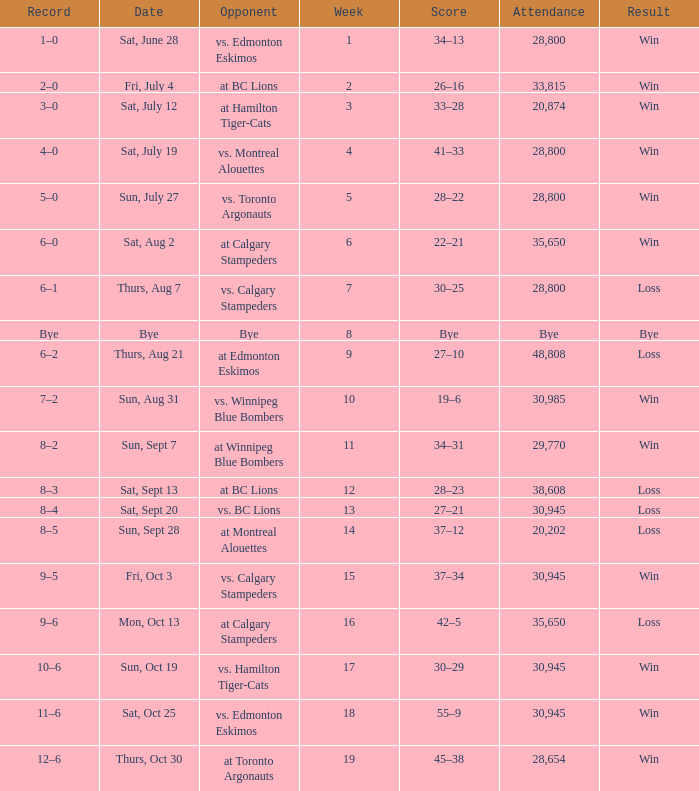Would you mind parsing the complete table? {'header': ['Record', 'Date', 'Opponent', 'Week', 'Score', 'Attendance', 'Result'], 'rows': [['1–0', 'Sat, June 28', 'vs. Edmonton Eskimos', '1', '34–13', '28,800', 'Win'], ['2–0', 'Fri, July 4', 'at BC Lions', '2', '26–16', '33,815', 'Win'], ['3–0', 'Sat, July 12', 'at Hamilton Tiger-Cats', '3', '33–28', '20,874', 'Win'], ['4–0', 'Sat, July 19', 'vs. Montreal Alouettes', '4', '41–33', '28,800', 'Win'], ['5–0', 'Sun, July 27', 'vs. Toronto Argonauts', '5', '28–22', '28,800', 'Win'], ['6–0', 'Sat, Aug 2', 'at Calgary Stampeders', '6', '22–21', '35,650', 'Win'], ['6–1', 'Thurs, Aug 7', 'vs. Calgary Stampeders', '7', '30–25', '28,800', 'Loss'], ['Bye', 'Bye', 'Bye', '8', 'Bye', 'Bye', 'Bye'], ['6–2', 'Thurs, Aug 21', 'at Edmonton Eskimos', '9', '27–10', '48,808', 'Loss'], ['7–2', 'Sun, Aug 31', 'vs. Winnipeg Blue Bombers', '10', '19–6', '30,985', 'Win'], ['8–2', 'Sun, Sept 7', 'at Winnipeg Blue Bombers', '11', '34–31', '29,770', 'Win'], ['8–3', 'Sat, Sept 13', 'at BC Lions', '12', '28–23', '38,608', 'Loss'], ['8–4', 'Sat, Sept 20', 'vs. BC Lions', '13', '27–21', '30,945', 'Loss'], ['8–5', 'Sun, Sept 28', 'at Montreal Alouettes', '14', '37–12', '20,202', 'Loss'], ['9–5', 'Fri, Oct 3', 'vs. Calgary Stampeders', '15', '37–34', '30,945', 'Win'], ['9–6', 'Mon, Oct 13', 'at Calgary Stampeders', '16', '42–5', '35,650', 'Loss'], ['10–6', 'Sun, Oct 19', 'vs. Hamilton Tiger-Cats', '17', '30–29', '30,945', 'Win'], ['11–6', 'Sat, Oct 25', 'vs. Edmonton Eskimos', '18', '55–9', '30,945', 'Win'], ['12–6', 'Thurs, Oct 30', 'at Toronto Argonauts', '19', '45–38', '28,654', 'Win']]} What was the record the the match against vs. calgary stampeders before week 15? 6–1. 